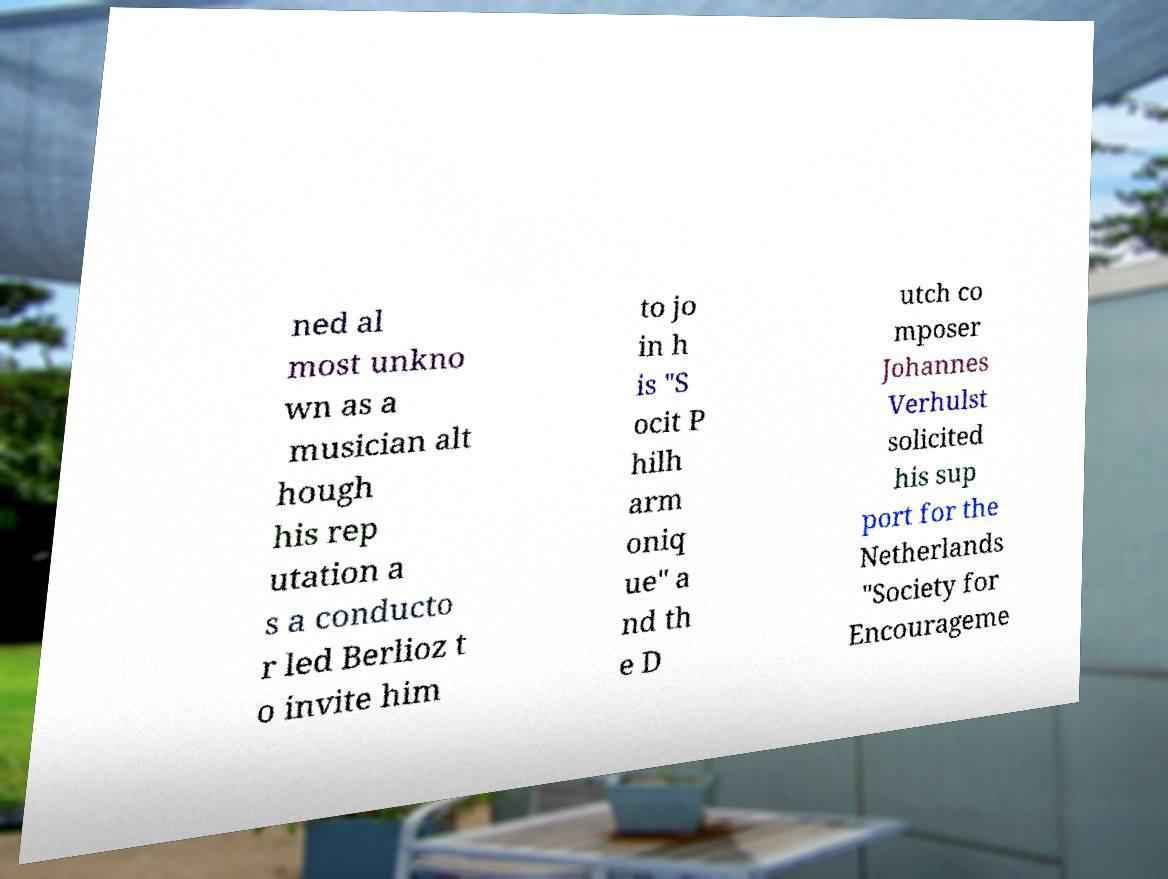Could you assist in decoding the text presented in this image and type it out clearly? ned al most unkno wn as a musician alt hough his rep utation a s a conducto r led Berlioz t o invite him to jo in h is "S ocit P hilh arm oniq ue" a nd th e D utch co mposer Johannes Verhulst solicited his sup port for the Netherlands "Society for Encourageme 